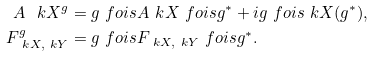<formula> <loc_0><loc_0><loc_500><loc_500>A _ { \ } k X ^ { g } & = g \ f o i s A _ { \ } k X \ f o i s g ^ { \ast } + i g \ f o i s \ k X ( g ^ { \ast } ) , \\ F _ { \ k X , \ k Y } ^ { g } & = g \ f o i s F _ { \ k X , \ k Y } \ f o i s g ^ { \ast } .</formula> 